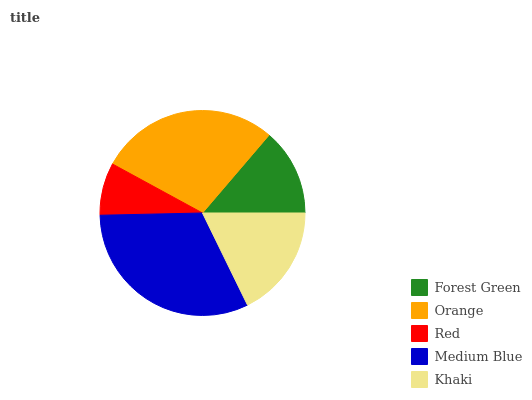Is Red the minimum?
Answer yes or no. Yes. Is Medium Blue the maximum?
Answer yes or no. Yes. Is Orange the minimum?
Answer yes or no. No. Is Orange the maximum?
Answer yes or no. No. Is Orange greater than Forest Green?
Answer yes or no. Yes. Is Forest Green less than Orange?
Answer yes or no. Yes. Is Forest Green greater than Orange?
Answer yes or no. No. Is Orange less than Forest Green?
Answer yes or no. No. Is Khaki the high median?
Answer yes or no. Yes. Is Khaki the low median?
Answer yes or no. Yes. Is Medium Blue the high median?
Answer yes or no. No. Is Medium Blue the low median?
Answer yes or no. No. 